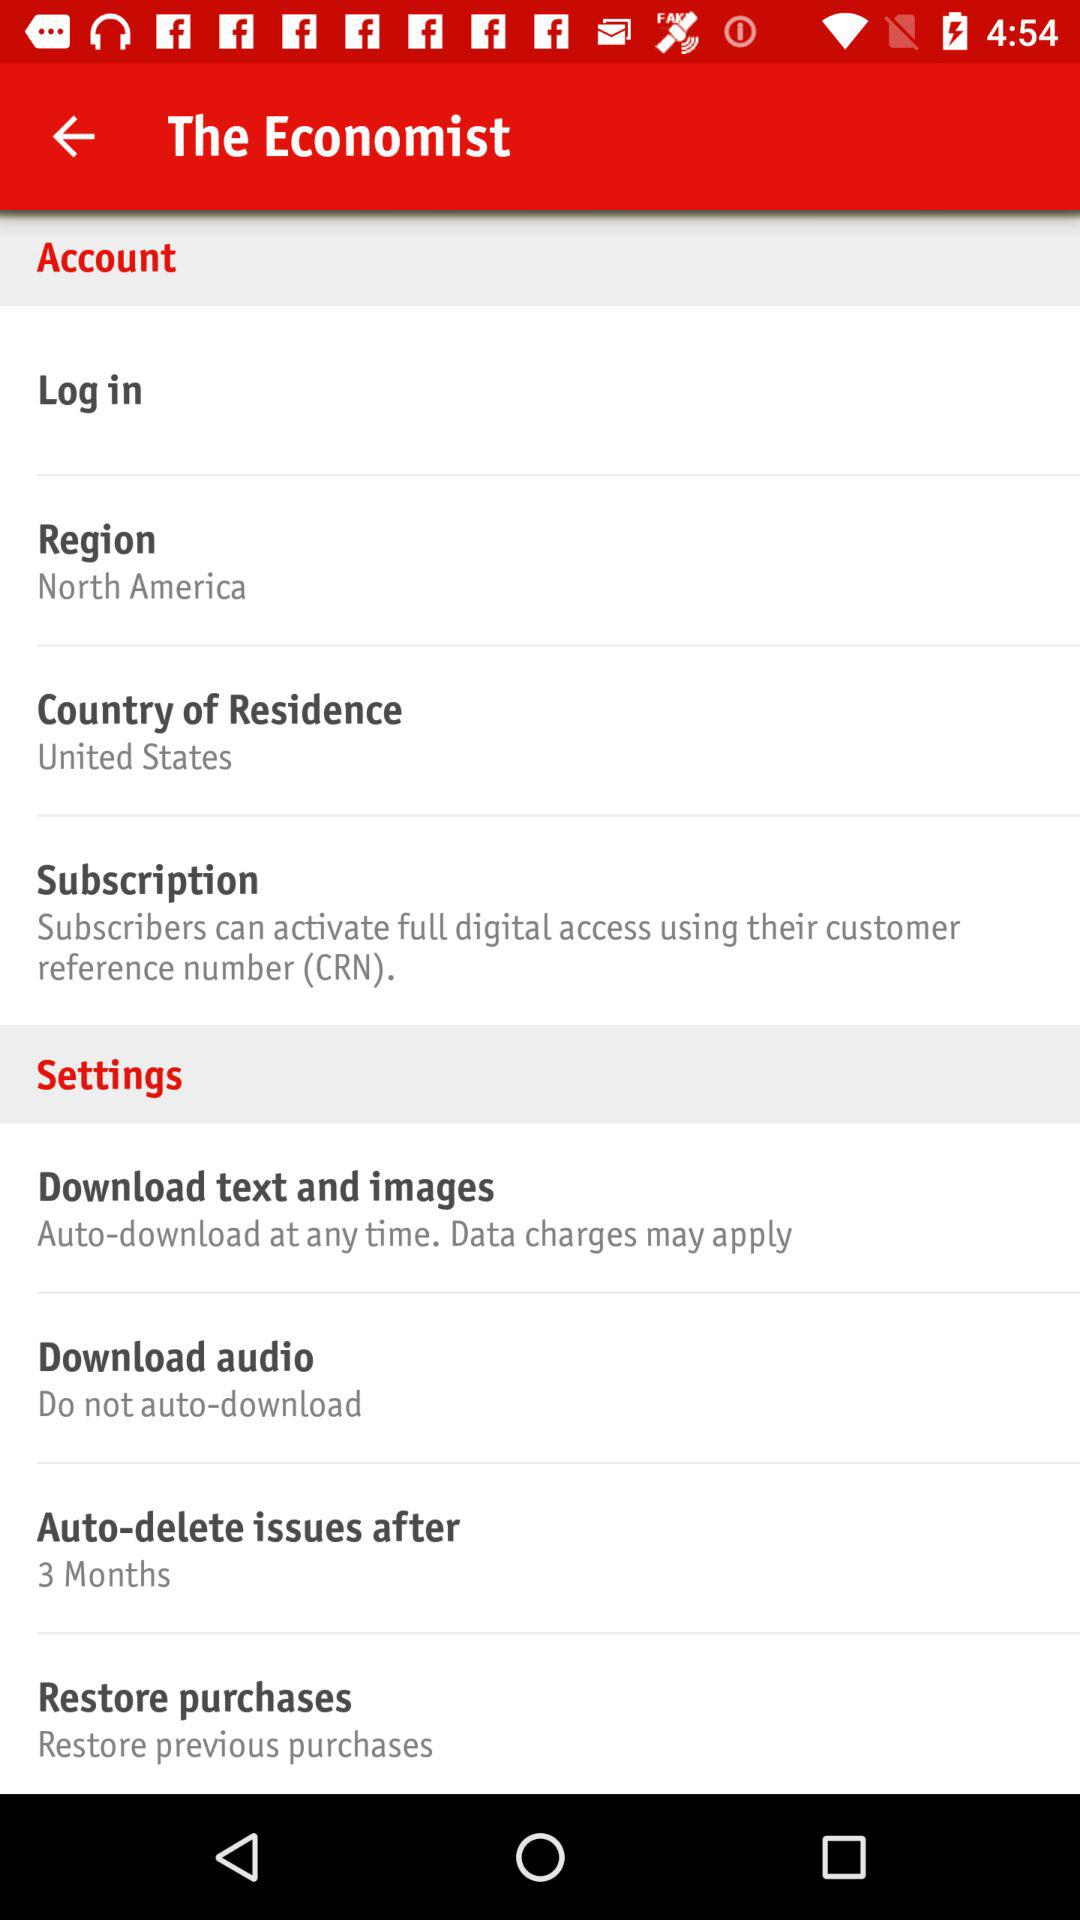Through what number do subscribers activate full digital access? Subscribers can activate full digital access through a "customer reference number". 